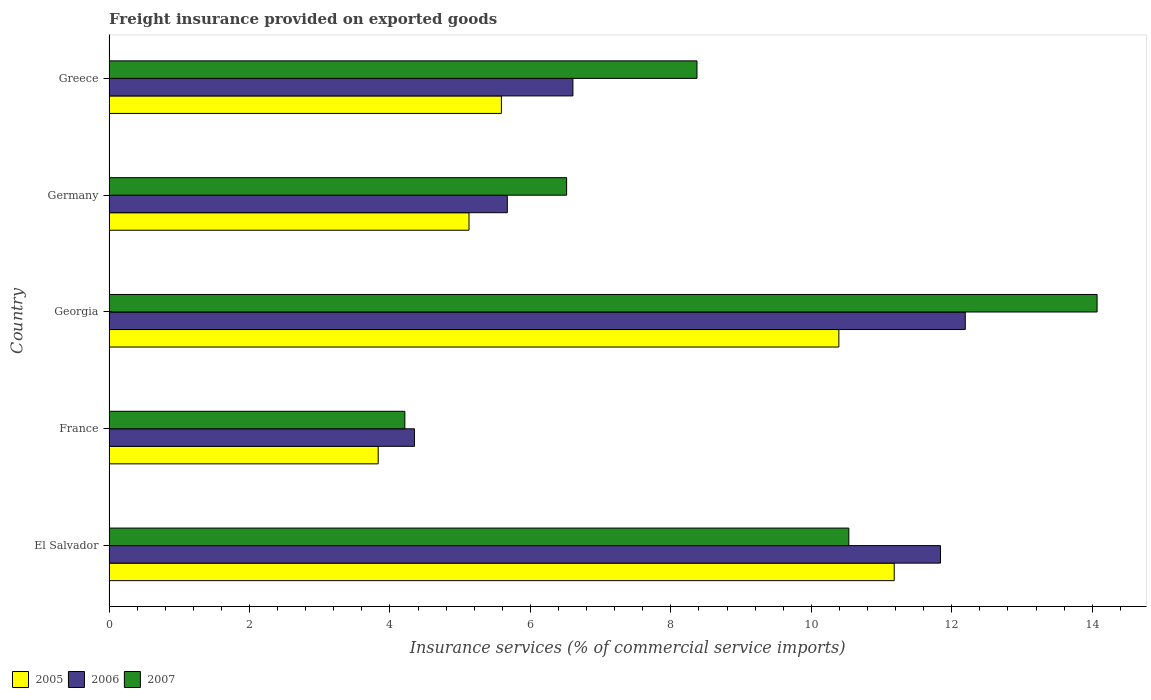How many bars are there on the 5th tick from the top?
Provide a short and direct response. 3. What is the label of the 4th group of bars from the top?
Your answer should be very brief. France. What is the freight insurance provided on exported goods in 2007 in France?
Your answer should be very brief. 4.21. Across all countries, what is the maximum freight insurance provided on exported goods in 2007?
Provide a short and direct response. 14.07. Across all countries, what is the minimum freight insurance provided on exported goods in 2006?
Provide a short and direct response. 4.35. In which country was the freight insurance provided on exported goods in 2007 maximum?
Your response must be concise. Georgia. In which country was the freight insurance provided on exported goods in 2005 minimum?
Your answer should be very brief. France. What is the total freight insurance provided on exported goods in 2007 in the graph?
Give a very brief answer. 43.7. What is the difference between the freight insurance provided on exported goods in 2007 in El Salvador and that in Germany?
Give a very brief answer. 4.02. What is the difference between the freight insurance provided on exported goods in 2005 in Germany and the freight insurance provided on exported goods in 2007 in France?
Your answer should be very brief. 0.91. What is the average freight insurance provided on exported goods in 2005 per country?
Provide a short and direct response. 7.22. What is the difference between the freight insurance provided on exported goods in 2006 and freight insurance provided on exported goods in 2007 in France?
Make the answer very short. 0.14. What is the ratio of the freight insurance provided on exported goods in 2005 in France to that in Georgia?
Provide a succinct answer. 0.37. Is the freight insurance provided on exported goods in 2005 in France less than that in Greece?
Your answer should be very brief. Yes. What is the difference between the highest and the second highest freight insurance provided on exported goods in 2006?
Give a very brief answer. 0.35. What is the difference between the highest and the lowest freight insurance provided on exported goods in 2007?
Provide a succinct answer. 9.86. How many bars are there?
Offer a very short reply. 15. Are the values on the major ticks of X-axis written in scientific E-notation?
Make the answer very short. No. How many legend labels are there?
Your response must be concise. 3. What is the title of the graph?
Give a very brief answer. Freight insurance provided on exported goods. Does "1997" appear as one of the legend labels in the graph?
Provide a short and direct response. No. What is the label or title of the X-axis?
Keep it short and to the point. Insurance services (% of commercial service imports). What is the Insurance services (% of commercial service imports) of 2005 in El Salvador?
Give a very brief answer. 11.18. What is the Insurance services (% of commercial service imports) in 2006 in El Salvador?
Provide a succinct answer. 11.84. What is the Insurance services (% of commercial service imports) of 2007 in El Salvador?
Provide a succinct answer. 10.53. What is the Insurance services (% of commercial service imports) in 2005 in France?
Provide a succinct answer. 3.83. What is the Insurance services (% of commercial service imports) in 2006 in France?
Your answer should be compact. 4.35. What is the Insurance services (% of commercial service imports) of 2007 in France?
Give a very brief answer. 4.21. What is the Insurance services (% of commercial service imports) in 2005 in Georgia?
Make the answer very short. 10.39. What is the Insurance services (% of commercial service imports) in 2006 in Georgia?
Offer a very short reply. 12.19. What is the Insurance services (% of commercial service imports) in 2007 in Georgia?
Offer a terse response. 14.07. What is the Insurance services (% of commercial service imports) in 2005 in Germany?
Your response must be concise. 5.13. What is the Insurance services (% of commercial service imports) of 2006 in Germany?
Keep it short and to the point. 5.67. What is the Insurance services (% of commercial service imports) of 2007 in Germany?
Ensure brevity in your answer.  6.52. What is the Insurance services (% of commercial service imports) of 2005 in Greece?
Offer a terse response. 5.59. What is the Insurance services (% of commercial service imports) in 2006 in Greece?
Offer a terse response. 6.61. What is the Insurance services (% of commercial service imports) in 2007 in Greece?
Your response must be concise. 8.37. Across all countries, what is the maximum Insurance services (% of commercial service imports) of 2005?
Your answer should be compact. 11.18. Across all countries, what is the maximum Insurance services (% of commercial service imports) in 2006?
Keep it short and to the point. 12.19. Across all countries, what is the maximum Insurance services (% of commercial service imports) in 2007?
Provide a succinct answer. 14.07. Across all countries, what is the minimum Insurance services (% of commercial service imports) of 2005?
Give a very brief answer. 3.83. Across all countries, what is the minimum Insurance services (% of commercial service imports) of 2006?
Ensure brevity in your answer.  4.35. Across all countries, what is the minimum Insurance services (% of commercial service imports) of 2007?
Ensure brevity in your answer.  4.21. What is the total Insurance services (% of commercial service imports) of 2005 in the graph?
Offer a terse response. 36.12. What is the total Insurance services (% of commercial service imports) in 2006 in the graph?
Your answer should be compact. 40.66. What is the total Insurance services (% of commercial service imports) of 2007 in the graph?
Offer a terse response. 43.7. What is the difference between the Insurance services (% of commercial service imports) in 2005 in El Salvador and that in France?
Offer a very short reply. 7.35. What is the difference between the Insurance services (% of commercial service imports) of 2006 in El Salvador and that in France?
Your answer should be very brief. 7.49. What is the difference between the Insurance services (% of commercial service imports) in 2007 in El Salvador and that in France?
Your answer should be compact. 6.32. What is the difference between the Insurance services (% of commercial service imports) of 2005 in El Salvador and that in Georgia?
Ensure brevity in your answer.  0.79. What is the difference between the Insurance services (% of commercial service imports) of 2006 in El Salvador and that in Georgia?
Your answer should be very brief. -0.35. What is the difference between the Insurance services (% of commercial service imports) of 2007 in El Salvador and that in Georgia?
Provide a succinct answer. -3.54. What is the difference between the Insurance services (% of commercial service imports) of 2005 in El Salvador and that in Germany?
Your response must be concise. 6.05. What is the difference between the Insurance services (% of commercial service imports) in 2006 in El Salvador and that in Germany?
Your response must be concise. 6.17. What is the difference between the Insurance services (% of commercial service imports) of 2007 in El Salvador and that in Germany?
Provide a short and direct response. 4.02. What is the difference between the Insurance services (% of commercial service imports) of 2005 in El Salvador and that in Greece?
Your response must be concise. 5.59. What is the difference between the Insurance services (% of commercial service imports) in 2006 in El Salvador and that in Greece?
Ensure brevity in your answer.  5.23. What is the difference between the Insurance services (% of commercial service imports) in 2007 in El Salvador and that in Greece?
Provide a short and direct response. 2.16. What is the difference between the Insurance services (% of commercial service imports) of 2005 in France and that in Georgia?
Provide a short and direct response. -6.56. What is the difference between the Insurance services (% of commercial service imports) in 2006 in France and that in Georgia?
Offer a terse response. -7.84. What is the difference between the Insurance services (% of commercial service imports) of 2007 in France and that in Georgia?
Your response must be concise. -9.86. What is the difference between the Insurance services (% of commercial service imports) in 2005 in France and that in Germany?
Provide a short and direct response. -1.29. What is the difference between the Insurance services (% of commercial service imports) of 2006 in France and that in Germany?
Give a very brief answer. -1.32. What is the difference between the Insurance services (% of commercial service imports) in 2007 in France and that in Germany?
Offer a terse response. -2.3. What is the difference between the Insurance services (% of commercial service imports) in 2005 in France and that in Greece?
Your response must be concise. -1.75. What is the difference between the Insurance services (% of commercial service imports) in 2006 in France and that in Greece?
Provide a short and direct response. -2.26. What is the difference between the Insurance services (% of commercial service imports) in 2007 in France and that in Greece?
Your answer should be very brief. -4.16. What is the difference between the Insurance services (% of commercial service imports) in 2005 in Georgia and that in Germany?
Keep it short and to the point. 5.27. What is the difference between the Insurance services (% of commercial service imports) of 2006 in Georgia and that in Germany?
Offer a very short reply. 6.52. What is the difference between the Insurance services (% of commercial service imports) in 2007 in Georgia and that in Germany?
Your answer should be very brief. 7.55. What is the difference between the Insurance services (% of commercial service imports) of 2005 in Georgia and that in Greece?
Your answer should be very brief. 4.8. What is the difference between the Insurance services (% of commercial service imports) of 2006 in Georgia and that in Greece?
Keep it short and to the point. 5.59. What is the difference between the Insurance services (% of commercial service imports) in 2007 in Georgia and that in Greece?
Provide a succinct answer. 5.7. What is the difference between the Insurance services (% of commercial service imports) of 2005 in Germany and that in Greece?
Ensure brevity in your answer.  -0.46. What is the difference between the Insurance services (% of commercial service imports) of 2006 in Germany and that in Greece?
Offer a very short reply. -0.93. What is the difference between the Insurance services (% of commercial service imports) of 2007 in Germany and that in Greece?
Ensure brevity in your answer.  -1.86. What is the difference between the Insurance services (% of commercial service imports) in 2005 in El Salvador and the Insurance services (% of commercial service imports) in 2006 in France?
Offer a very short reply. 6.83. What is the difference between the Insurance services (% of commercial service imports) of 2005 in El Salvador and the Insurance services (% of commercial service imports) of 2007 in France?
Offer a terse response. 6.97. What is the difference between the Insurance services (% of commercial service imports) of 2006 in El Salvador and the Insurance services (% of commercial service imports) of 2007 in France?
Provide a succinct answer. 7.63. What is the difference between the Insurance services (% of commercial service imports) of 2005 in El Salvador and the Insurance services (% of commercial service imports) of 2006 in Georgia?
Your answer should be very brief. -1.01. What is the difference between the Insurance services (% of commercial service imports) in 2005 in El Salvador and the Insurance services (% of commercial service imports) in 2007 in Georgia?
Offer a terse response. -2.89. What is the difference between the Insurance services (% of commercial service imports) in 2006 in El Salvador and the Insurance services (% of commercial service imports) in 2007 in Georgia?
Offer a terse response. -2.23. What is the difference between the Insurance services (% of commercial service imports) of 2005 in El Salvador and the Insurance services (% of commercial service imports) of 2006 in Germany?
Your answer should be very brief. 5.51. What is the difference between the Insurance services (% of commercial service imports) in 2005 in El Salvador and the Insurance services (% of commercial service imports) in 2007 in Germany?
Make the answer very short. 4.66. What is the difference between the Insurance services (% of commercial service imports) in 2006 in El Salvador and the Insurance services (% of commercial service imports) in 2007 in Germany?
Ensure brevity in your answer.  5.32. What is the difference between the Insurance services (% of commercial service imports) of 2005 in El Salvador and the Insurance services (% of commercial service imports) of 2006 in Greece?
Offer a very short reply. 4.58. What is the difference between the Insurance services (% of commercial service imports) of 2005 in El Salvador and the Insurance services (% of commercial service imports) of 2007 in Greece?
Make the answer very short. 2.81. What is the difference between the Insurance services (% of commercial service imports) of 2006 in El Salvador and the Insurance services (% of commercial service imports) of 2007 in Greece?
Keep it short and to the point. 3.47. What is the difference between the Insurance services (% of commercial service imports) in 2005 in France and the Insurance services (% of commercial service imports) in 2006 in Georgia?
Provide a succinct answer. -8.36. What is the difference between the Insurance services (% of commercial service imports) in 2005 in France and the Insurance services (% of commercial service imports) in 2007 in Georgia?
Offer a terse response. -10.24. What is the difference between the Insurance services (% of commercial service imports) of 2006 in France and the Insurance services (% of commercial service imports) of 2007 in Georgia?
Keep it short and to the point. -9.72. What is the difference between the Insurance services (% of commercial service imports) of 2005 in France and the Insurance services (% of commercial service imports) of 2006 in Germany?
Offer a very short reply. -1.84. What is the difference between the Insurance services (% of commercial service imports) of 2005 in France and the Insurance services (% of commercial service imports) of 2007 in Germany?
Provide a succinct answer. -2.68. What is the difference between the Insurance services (% of commercial service imports) of 2006 in France and the Insurance services (% of commercial service imports) of 2007 in Germany?
Make the answer very short. -2.17. What is the difference between the Insurance services (% of commercial service imports) in 2005 in France and the Insurance services (% of commercial service imports) in 2006 in Greece?
Ensure brevity in your answer.  -2.77. What is the difference between the Insurance services (% of commercial service imports) of 2005 in France and the Insurance services (% of commercial service imports) of 2007 in Greece?
Your answer should be compact. -4.54. What is the difference between the Insurance services (% of commercial service imports) of 2006 in France and the Insurance services (% of commercial service imports) of 2007 in Greece?
Keep it short and to the point. -4.02. What is the difference between the Insurance services (% of commercial service imports) of 2005 in Georgia and the Insurance services (% of commercial service imports) of 2006 in Germany?
Offer a very short reply. 4.72. What is the difference between the Insurance services (% of commercial service imports) of 2005 in Georgia and the Insurance services (% of commercial service imports) of 2007 in Germany?
Offer a terse response. 3.88. What is the difference between the Insurance services (% of commercial service imports) of 2006 in Georgia and the Insurance services (% of commercial service imports) of 2007 in Germany?
Keep it short and to the point. 5.68. What is the difference between the Insurance services (% of commercial service imports) of 2005 in Georgia and the Insurance services (% of commercial service imports) of 2006 in Greece?
Your answer should be compact. 3.79. What is the difference between the Insurance services (% of commercial service imports) in 2005 in Georgia and the Insurance services (% of commercial service imports) in 2007 in Greece?
Offer a terse response. 2.02. What is the difference between the Insurance services (% of commercial service imports) in 2006 in Georgia and the Insurance services (% of commercial service imports) in 2007 in Greece?
Ensure brevity in your answer.  3.82. What is the difference between the Insurance services (% of commercial service imports) of 2005 in Germany and the Insurance services (% of commercial service imports) of 2006 in Greece?
Give a very brief answer. -1.48. What is the difference between the Insurance services (% of commercial service imports) of 2005 in Germany and the Insurance services (% of commercial service imports) of 2007 in Greece?
Provide a succinct answer. -3.25. What is the difference between the Insurance services (% of commercial service imports) in 2006 in Germany and the Insurance services (% of commercial service imports) in 2007 in Greece?
Your response must be concise. -2.7. What is the average Insurance services (% of commercial service imports) of 2005 per country?
Your answer should be very brief. 7.22. What is the average Insurance services (% of commercial service imports) in 2006 per country?
Your answer should be compact. 8.13. What is the average Insurance services (% of commercial service imports) in 2007 per country?
Ensure brevity in your answer.  8.74. What is the difference between the Insurance services (% of commercial service imports) in 2005 and Insurance services (% of commercial service imports) in 2006 in El Salvador?
Provide a succinct answer. -0.66. What is the difference between the Insurance services (% of commercial service imports) in 2005 and Insurance services (% of commercial service imports) in 2007 in El Salvador?
Keep it short and to the point. 0.65. What is the difference between the Insurance services (% of commercial service imports) in 2006 and Insurance services (% of commercial service imports) in 2007 in El Salvador?
Offer a very short reply. 1.3. What is the difference between the Insurance services (% of commercial service imports) in 2005 and Insurance services (% of commercial service imports) in 2006 in France?
Your answer should be very brief. -0.52. What is the difference between the Insurance services (% of commercial service imports) in 2005 and Insurance services (% of commercial service imports) in 2007 in France?
Give a very brief answer. -0.38. What is the difference between the Insurance services (% of commercial service imports) in 2006 and Insurance services (% of commercial service imports) in 2007 in France?
Provide a short and direct response. 0.14. What is the difference between the Insurance services (% of commercial service imports) in 2005 and Insurance services (% of commercial service imports) in 2006 in Georgia?
Your response must be concise. -1.8. What is the difference between the Insurance services (% of commercial service imports) of 2005 and Insurance services (% of commercial service imports) of 2007 in Georgia?
Keep it short and to the point. -3.68. What is the difference between the Insurance services (% of commercial service imports) in 2006 and Insurance services (% of commercial service imports) in 2007 in Georgia?
Your response must be concise. -1.88. What is the difference between the Insurance services (% of commercial service imports) of 2005 and Insurance services (% of commercial service imports) of 2006 in Germany?
Ensure brevity in your answer.  -0.55. What is the difference between the Insurance services (% of commercial service imports) of 2005 and Insurance services (% of commercial service imports) of 2007 in Germany?
Provide a succinct answer. -1.39. What is the difference between the Insurance services (% of commercial service imports) of 2006 and Insurance services (% of commercial service imports) of 2007 in Germany?
Make the answer very short. -0.84. What is the difference between the Insurance services (% of commercial service imports) in 2005 and Insurance services (% of commercial service imports) in 2006 in Greece?
Ensure brevity in your answer.  -1.02. What is the difference between the Insurance services (% of commercial service imports) of 2005 and Insurance services (% of commercial service imports) of 2007 in Greece?
Ensure brevity in your answer.  -2.78. What is the difference between the Insurance services (% of commercial service imports) in 2006 and Insurance services (% of commercial service imports) in 2007 in Greece?
Your answer should be compact. -1.77. What is the ratio of the Insurance services (% of commercial service imports) in 2005 in El Salvador to that in France?
Your answer should be compact. 2.92. What is the ratio of the Insurance services (% of commercial service imports) in 2006 in El Salvador to that in France?
Offer a terse response. 2.72. What is the ratio of the Insurance services (% of commercial service imports) of 2007 in El Salvador to that in France?
Your answer should be compact. 2.5. What is the ratio of the Insurance services (% of commercial service imports) of 2005 in El Salvador to that in Georgia?
Make the answer very short. 1.08. What is the ratio of the Insurance services (% of commercial service imports) of 2007 in El Salvador to that in Georgia?
Give a very brief answer. 0.75. What is the ratio of the Insurance services (% of commercial service imports) of 2005 in El Salvador to that in Germany?
Keep it short and to the point. 2.18. What is the ratio of the Insurance services (% of commercial service imports) in 2006 in El Salvador to that in Germany?
Your answer should be very brief. 2.09. What is the ratio of the Insurance services (% of commercial service imports) in 2007 in El Salvador to that in Germany?
Your answer should be compact. 1.62. What is the ratio of the Insurance services (% of commercial service imports) in 2005 in El Salvador to that in Greece?
Your answer should be compact. 2. What is the ratio of the Insurance services (% of commercial service imports) in 2006 in El Salvador to that in Greece?
Make the answer very short. 1.79. What is the ratio of the Insurance services (% of commercial service imports) in 2007 in El Salvador to that in Greece?
Make the answer very short. 1.26. What is the ratio of the Insurance services (% of commercial service imports) of 2005 in France to that in Georgia?
Provide a short and direct response. 0.37. What is the ratio of the Insurance services (% of commercial service imports) of 2006 in France to that in Georgia?
Offer a very short reply. 0.36. What is the ratio of the Insurance services (% of commercial service imports) in 2007 in France to that in Georgia?
Ensure brevity in your answer.  0.3. What is the ratio of the Insurance services (% of commercial service imports) in 2005 in France to that in Germany?
Give a very brief answer. 0.75. What is the ratio of the Insurance services (% of commercial service imports) of 2006 in France to that in Germany?
Offer a terse response. 0.77. What is the ratio of the Insurance services (% of commercial service imports) in 2007 in France to that in Germany?
Provide a succinct answer. 0.65. What is the ratio of the Insurance services (% of commercial service imports) of 2005 in France to that in Greece?
Make the answer very short. 0.69. What is the ratio of the Insurance services (% of commercial service imports) of 2006 in France to that in Greece?
Offer a very short reply. 0.66. What is the ratio of the Insurance services (% of commercial service imports) in 2007 in France to that in Greece?
Provide a succinct answer. 0.5. What is the ratio of the Insurance services (% of commercial service imports) of 2005 in Georgia to that in Germany?
Make the answer very short. 2.03. What is the ratio of the Insurance services (% of commercial service imports) in 2006 in Georgia to that in Germany?
Provide a short and direct response. 2.15. What is the ratio of the Insurance services (% of commercial service imports) of 2007 in Georgia to that in Germany?
Offer a very short reply. 2.16. What is the ratio of the Insurance services (% of commercial service imports) in 2005 in Georgia to that in Greece?
Your answer should be very brief. 1.86. What is the ratio of the Insurance services (% of commercial service imports) in 2006 in Georgia to that in Greece?
Your answer should be compact. 1.85. What is the ratio of the Insurance services (% of commercial service imports) in 2007 in Georgia to that in Greece?
Your answer should be very brief. 1.68. What is the ratio of the Insurance services (% of commercial service imports) of 2005 in Germany to that in Greece?
Provide a succinct answer. 0.92. What is the ratio of the Insurance services (% of commercial service imports) in 2006 in Germany to that in Greece?
Give a very brief answer. 0.86. What is the ratio of the Insurance services (% of commercial service imports) of 2007 in Germany to that in Greece?
Keep it short and to the point. 0.78. What is the difference between the highest and the second highest Insurance services (% of commercial service imports) in 2005?
Ensure brevity in your answer.  0.79. What is the difference between the highest and the second highest Insurance services (% of commercial service imports) in 2006?
Provide a succinct answer. 0.35. What is the difference between the highest and the second highest Insurance services (% of commercial service imports) of 2007?
Provide a succinct answer. 3.54. What is the difference between the highest and the lowest Insurance services (% of commercial service imports) in 2005?
Your answer should be very brief. 7.35. What is the difference between the highest and the lowest Insurance services (% of commercial service imports) in 2006?
Give a very brief answer. 7.84. What is the difference between the highest and the lowest Insurance services (% of commercial service imports) of 2007?
Ensure brevity in your answer.  9.86. 